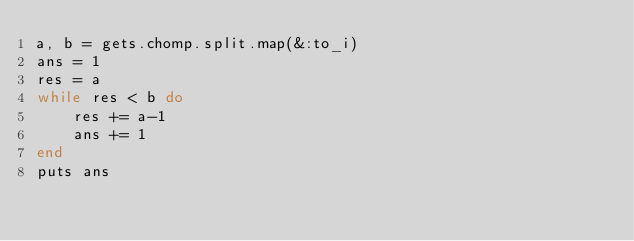<code> <loc_0><loc_0><loc_500><loc_500><_Ruby_>a, b = gets.chomp.split.map(&:to_i)
ans = 1
res = a
while res < b do
    res += a-1
    ans += 1
end
puts ans</code> 